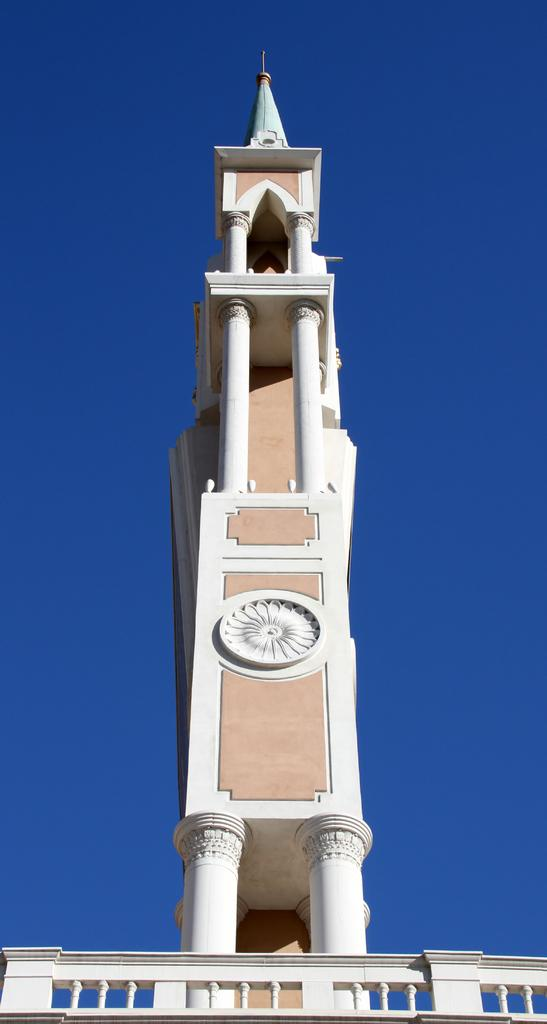What type of structure is present in the image? There is a building in the image. What colors are used for the building? The building is in white and brown colors. Is there any architectural feature associated with the building? Yes, there is a railing associated with the building. What can be seen in the background of the image? The sky is visible in the background of the image. What type of animal is causing trouble in the image? There is no animal present in the image, nor is there any indication of trouble. 